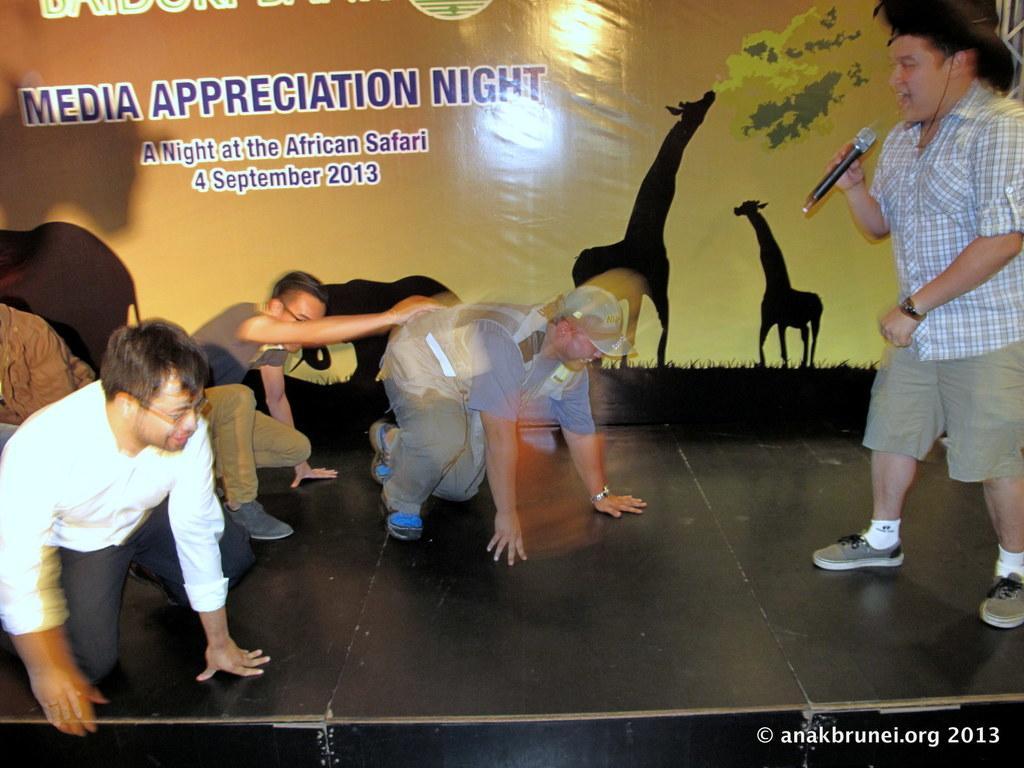Describe this image in one or two sentences. In this image I can see few people were on the right side I can see one man is standing and I can see he is holding a mic. I can also see he is wearing shirt, shorts, white socks, shoes and a hat. In the background I can see a board and on it I can see something is written. I can also see few depiction pictures on the board and on the bottom right side of this image I can see a watermark. I can also see this image is little bit blurry. 